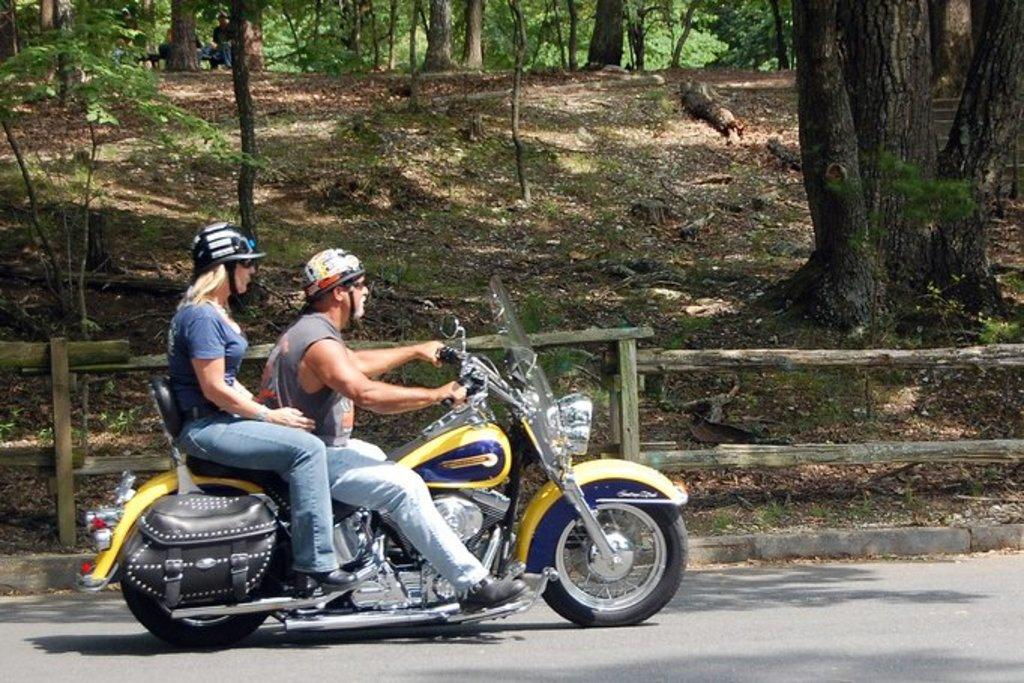How many people are in the image? There are two people in the image. What is one person doing in the image? One person is riding a motorcycle. What is the other person doing in the image? The other person is sitting on the back of the motorcycle. Can you describe the setting of the image? There are people sitting in the background, inside a forest. What type of substance can be seen on the ground in the image? There is no substance mentioned or visible on the ground in the image. Can you spot a wren in the image? There is no wren present in the image. 